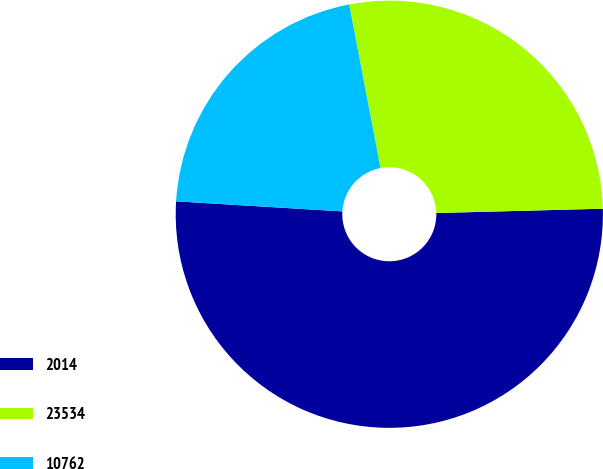Convert chart. <chart><loc_0><loc_0><loc_500><loc_500><pie_chart><fcel>2014<fcel>23534<fcel>10762<nl><fcel>51.38%<fcel>27.6%<fcel>21.03%<nl></chart> 